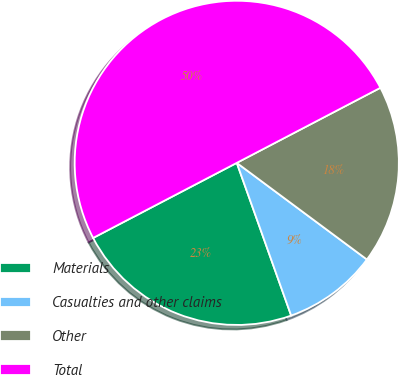<chart> <loc_0><loc_0><loc_500><loc_500><pie_chart><fcel>Materials<fcel>Casualties and other claims<fcel>Other<fcel>Total<nl><fcel>22.78%<fcel>9.39%<fcel>17.83%<fcel>50.0%<nl></chart> 